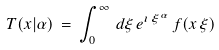Convert formula to latex. <formula><loc_0><loc_0><loc_500><loc_500>T ( x | \alpha ) \, = \, \int _ { 0 } ^ { \infty } \, d \xi \, e ^ { \imath \, \xi ^ { \alpha } } \, f ( x \, \xi )</formula> 